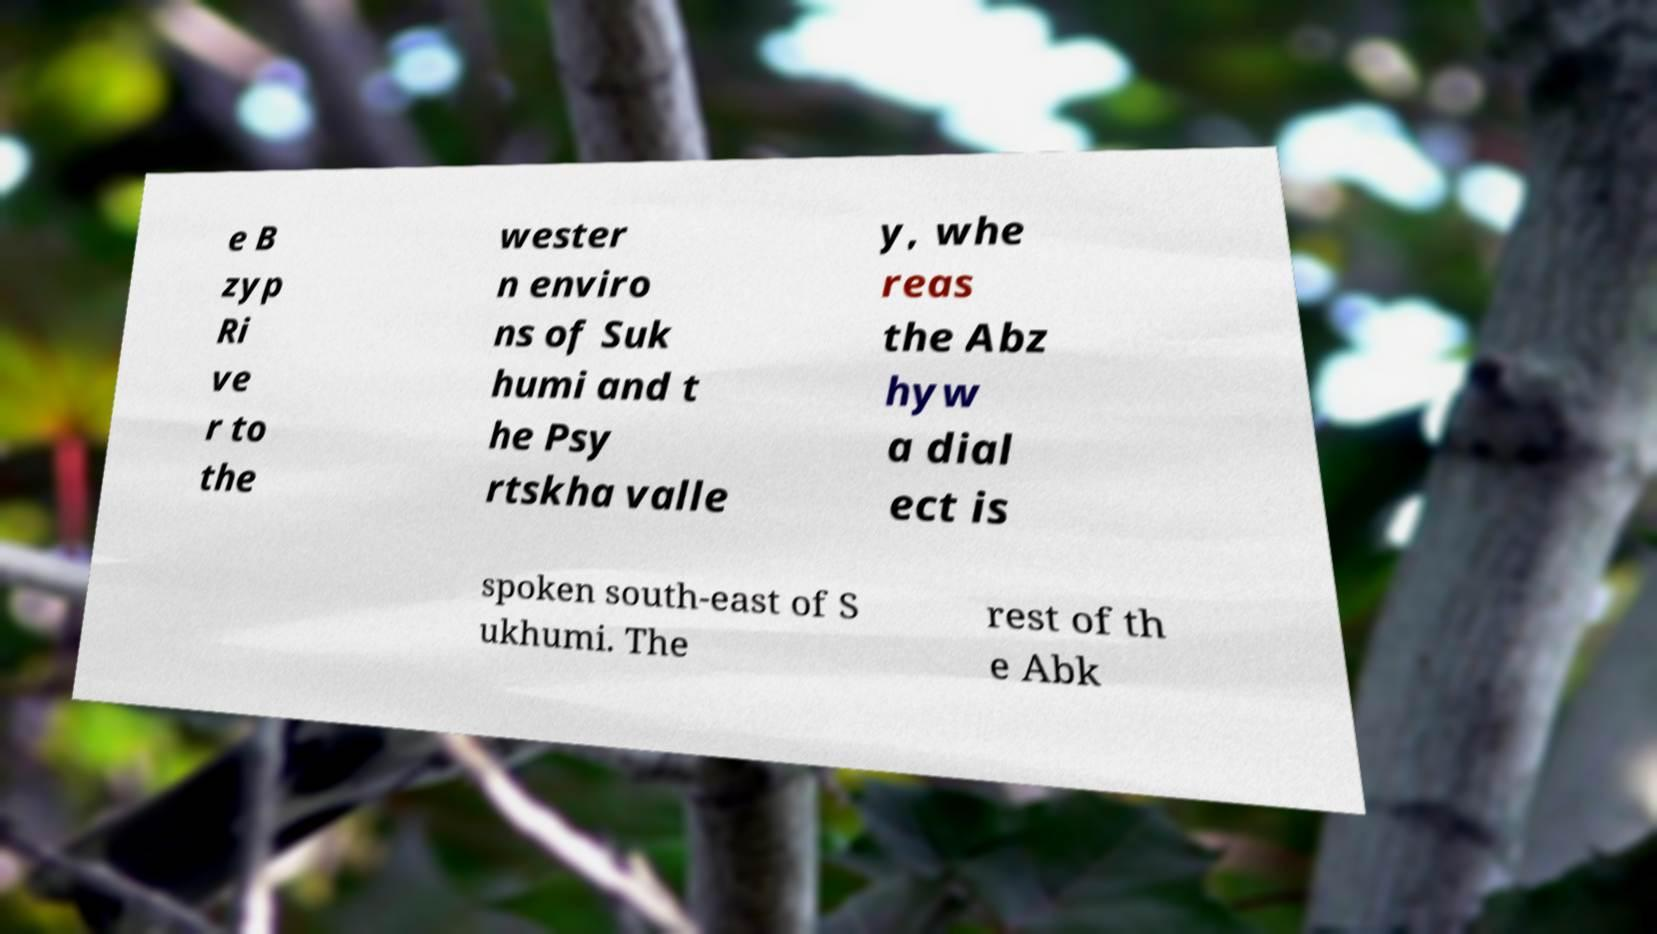Can you read and provide the text displayed in the image?This photo seems to have some interesting text. Can you extract and type it out for me? e B zyp Ri ve r to the wester n enviro ns of Suk humi and t he Psy rtskha valle y, whe reas the Abz hyw a dial ect is spoken south-east of S ukhumi. The rest of th e Abk 